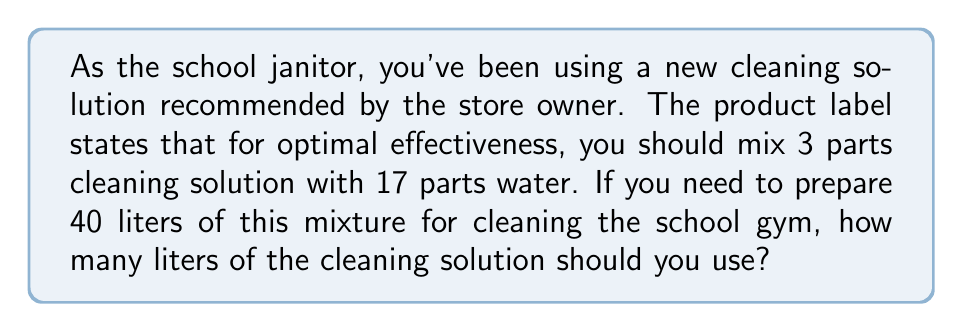Give your solution to this math problem. Let's approach this step-by-step:

1) First, we need to understand the ratio given:
   3 parts cleaning solution : 17 parts water

2) This means that for every 20 parts of the mixture (3 + 17 = 20), 3 parts are cleaning solution.

3) We can express this as a fraction:
   $\frac{3}{20}$ of the mixture is cleaning solution

4) Now, we need to find out how many liters of cleaning solution are needed for 40 liters of mixture.

5) We can set up the following equation:
   $\frac{x}{40} = \frac{3}{20}$, where $x$ is the amount of cleaning solution in liters

6) Cross multiply:
   $20x = 3 \cdot 40$

7) Simplify the right side:
   $20x = 120$

8) Divide both sides by 20:
   $x = \frac{120}{20} = 6$

Therefore, you need 6 liters of cleaning solution to make 40 liters of the mixture.
Answer: 6 liters of cleaning solution 